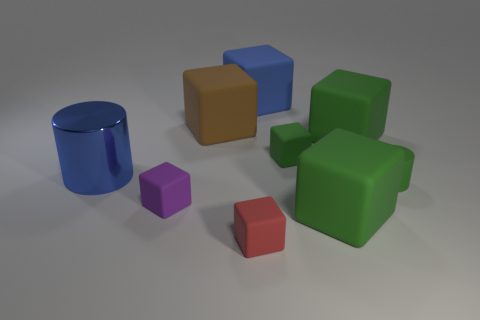Subtract all green cubes. How many were subtracted if there are1green cubes left? 2 Subtract all green rubber blocks. How many blocks are left? 4 Subtract all red blocks. How many blocks are left? 6 Subtract all blue rubber objects. Subtract all tiny objects. How many objects are left? 4 Add 4 cylinders. How many cylinders are left? 6 Add 2 brown blocks. How many brown blocks exist? 3 Subtract 0 blue spheres. How many objects are left? 9 Subtract all cubes. How many objects are left? 2 Subtract 3 blocks. How many blocks are left? 4 Subtract all cyan blocks. Subtract all cyan cylinders. How many blocks are left? 7 